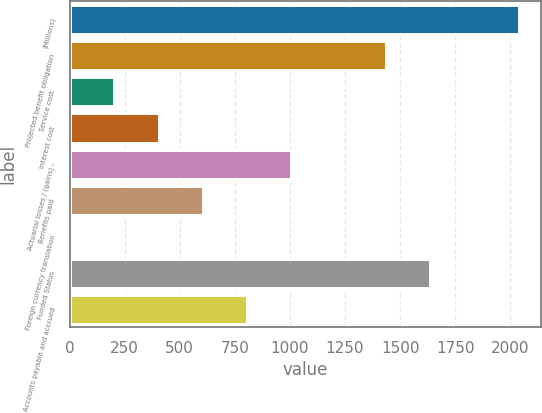Convert chart to OTSL. <chart><loc_0><loc_0><loc_500><loc_500><bar_chart><fcel>(Millions)<fcel>Projected benefit obligation<fcel>Service cost<fcel>Interest cost<fcel>Actuarial losses / (gains) -<fcel>Benefits paid<fcel>Foreign currency translation<fcel>Funded Status<fcel>Accounts payable and accrued<nl><fcel>2038.2<fcel>1435.8<fcel>203.8<fcel>404.6<fcel>1007<fcel>605.4<fcel>3<fcel>1636.6<fcel>806.2<nl></chart> 